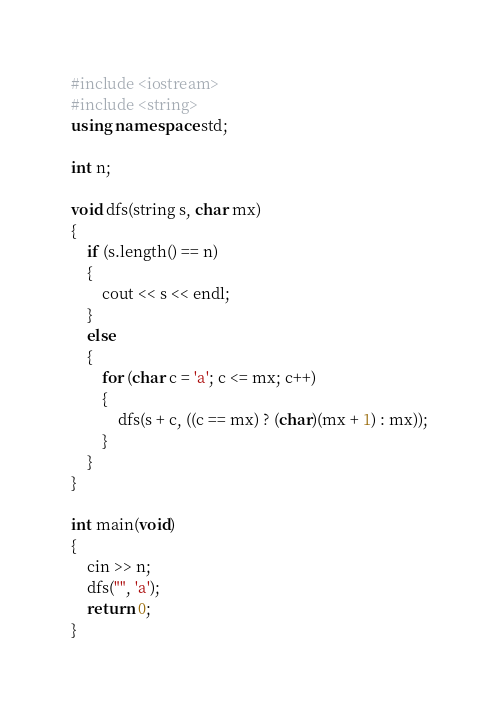<code> <loc_0><loc_0><loc_500><loc_500><_C++_>#include <iostream>
#include <string>
using namespace std;

int n;

void dfs(string s, char mx)
{
    if (s.length() == n)
    {
        cout << s << endl;
    }
    else
    {
        for (char c = 'a'; c <= mx; c++)
        {
            dfs(s + c, ((c == mx) ? (char)(mx + 1) : mx));
        }
    }
}

int main(void)
{
    cin >> n;
    dfs("", 'a');
    return 0;
}
</code> 